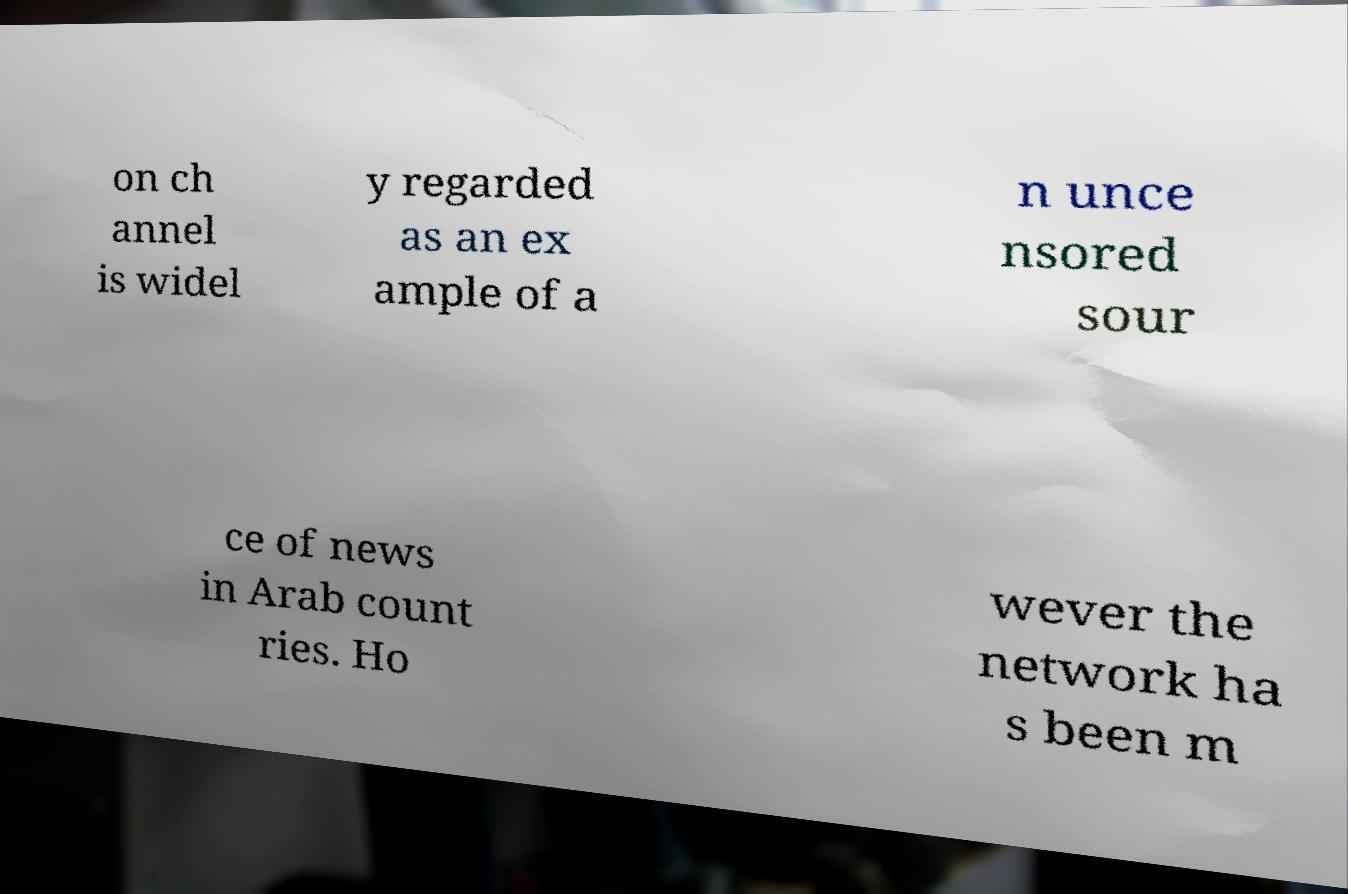Can you read and provide the text displayed in the image?This photo seems to have some interesting text. Can you extract and type it out for me? on ch annel is widel y regarded as an ex ample of a n unce nsored sour ce of news in Arab count ries. Ho wever the network ha s been m 